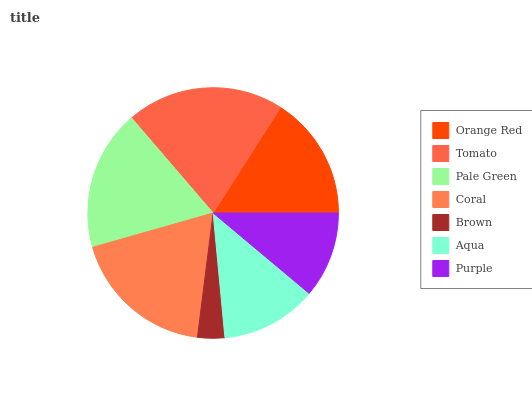Is Brown the minimum?
Answer yes or no. Yes. Is Tomato the maximum?
Answer yes or no. Yes. Is Pale Green the minimum?
Answer yes or no. No. Is Pale Green the maximum?
Answer yes or no. No. Is Tomato greater than Pale Green?
Answer yes or no. Yes. Is Pale Green less than Tomato?
Answer yes or no. Yes. Is Pale Green greater than Tomato?
Answer yes or no. No. Is Tomato less than Pale Green?
Answer yes or no. No. Is Orange Red the high median?
Answer yes or no. Yes. Is Orange Red the low median?
Answer yes or no. Yes. Is Coral the high median?
Answer yes or no. No. Is Purple the low median?
Answer yes or no. No. 